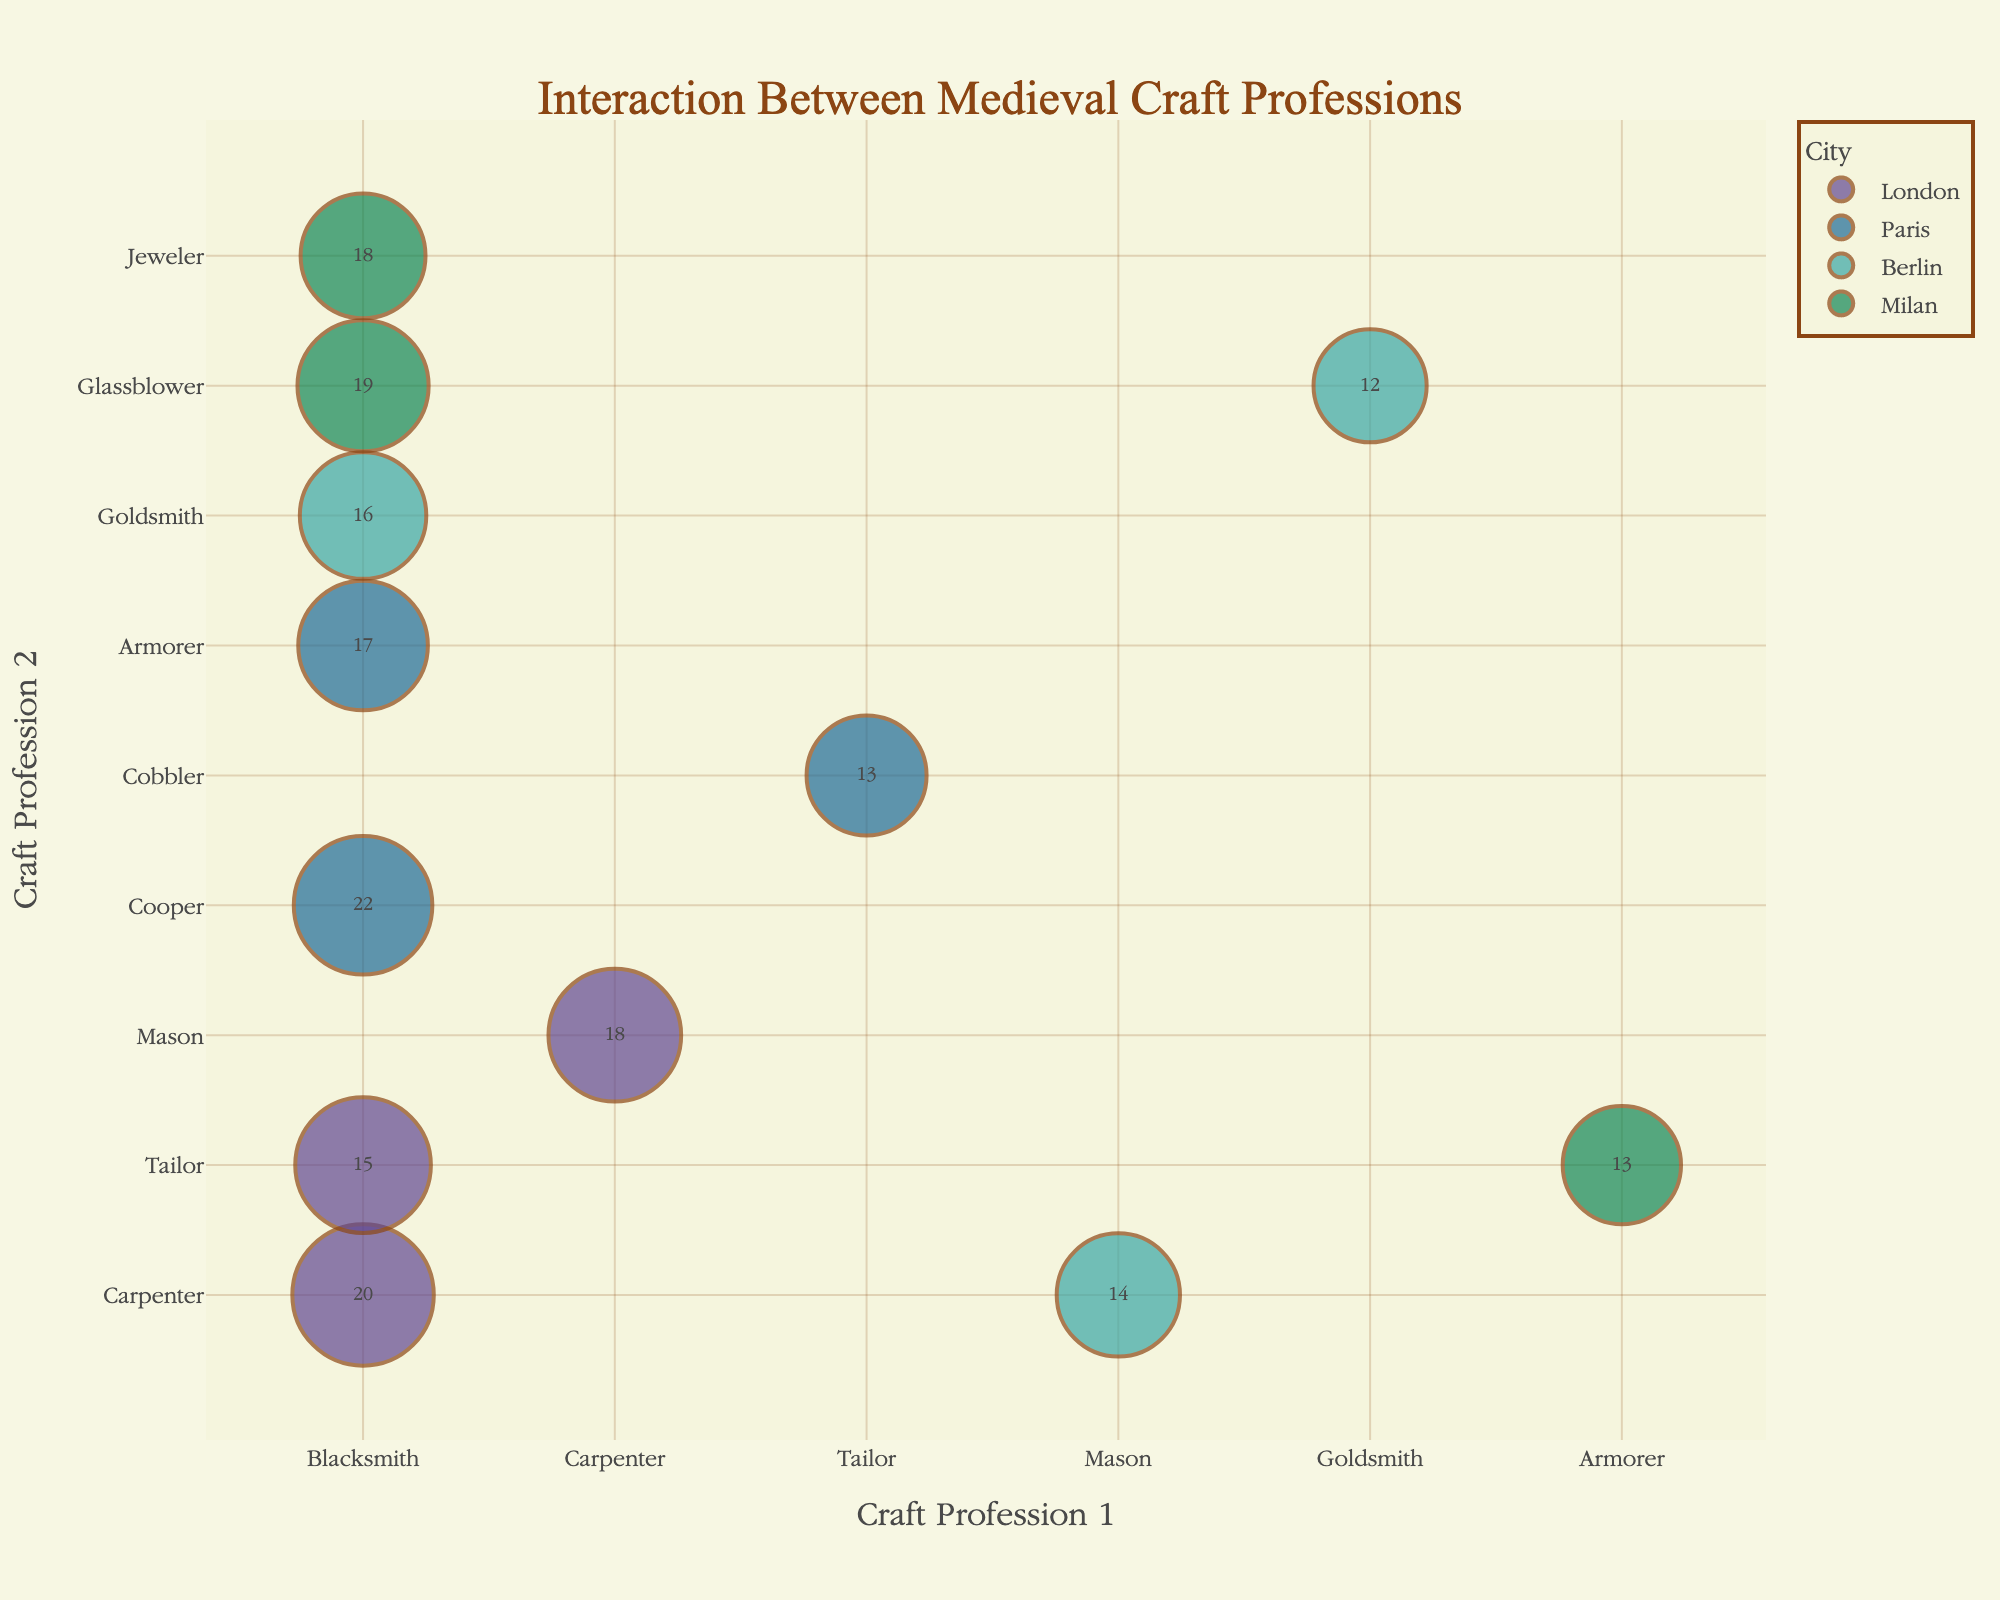What is the title of the plot? The title is located at the top center of the plot. It uses a large and decorative font, making it easily noticeable.
Answer: Interaction Between Medieval Craft Professions How many cities are represented in the plot? Count the number of unique colors or hover labels representing the cities.
Answer: Four (London, Paris, Berlin, Milan) Which interaction between craft professions in London has the highest Interaction Frequency? Look for the largest number among the text inside the bubbles for the city "London".
Answer: Blacksmith and Carpenter (20) Which craft professions in Milan had the highest Audience Size? Identify the largest bubble size for the city "Milan".
Answer: Blacksmith and Glassblower (215) What's the average Impact Score of interactions in Milan? Calculate the average by summing the Impact Scores for Milan and dividing by the number of interactions in Milan.
Answer: (82 + 64 + 79) / 3 = 75 Which city has the smallest bubble in the plot, and which craft professions does it represent? Identify the smallest bubble visually and check its corresponding labels.
Answer: Berlin, Goldsmith and Glassblower Compare the Interaction Frequency between Blacksmith and Cooper in Paris and Blacksmith and Jeweler in Milan. Which is higher? Find both interactions on the plot and compare the numbers indicated within the bubbles.
Answer: Blacksmith and Cooper in Paris (22) is higher How does the Interaction Frequency of Blacksmith and Carpenter in London compare to that of Mason and Carpenter in Berlin? Locate both bubbles and compare the numbers inside them.
Answer: Blacksmith and Carpenter in London (20) is higher than Mason and Carpenter in Berlin (14) Which interaction in Milan has an Impact Score close to the Interaction Frequency of Blacksmith and Tailor in London? Find the Interaction Frequency of Blacksmith and Tailor in London (15) and look for a similar Impact Score in Milan interactions.
Answer: Armorer and Tailor (64 is close to 70) What's the combined Audience Size of interactions involving Blacksmiths in Paris? Sum the Audience Sizes of all interactions with Blacksmiths in Paris.
Answer: 240 + 210 = 450 